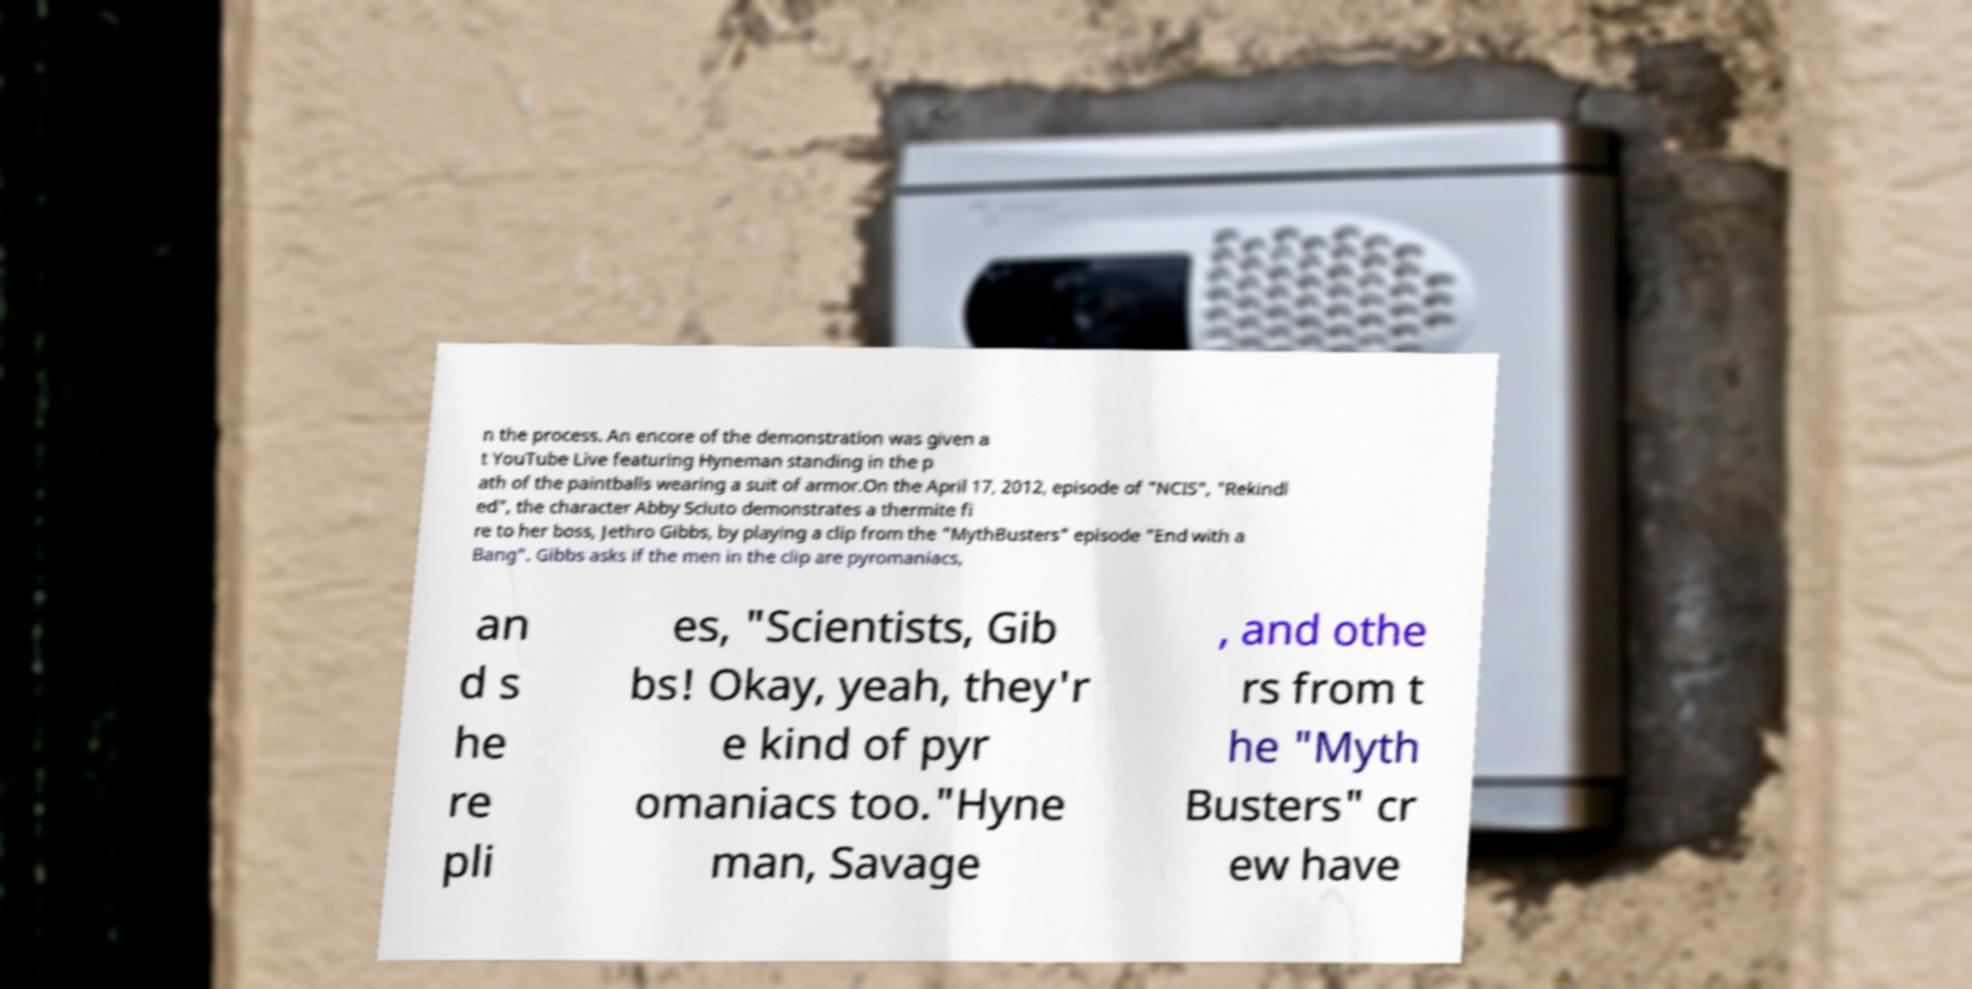I need the written content from this picture converted into text. Can you do that? n the process. An encore of the demonstration was given a t YouTube Live featuring Hyneman standing in the p ath of the paintballs wearing a suit of armor.On the April 17, 2012, episode of "NCIS", "Rekindl ed", the character Abby Sciuto demonstrates a thermite fi re to her boss, Jethro Gibbs, by playing a clip from the "MythBusters" episode "End with a Bang". Gibbs asks if the men in the clip are pyromaniacs, an d s he re pli es, "Scientists, Gib bs! Okay, yeah, they'r e kind of pyr omaniacs too."Hyne man, Savage , and othe rs from t he "Myth Busters" cr ew have 